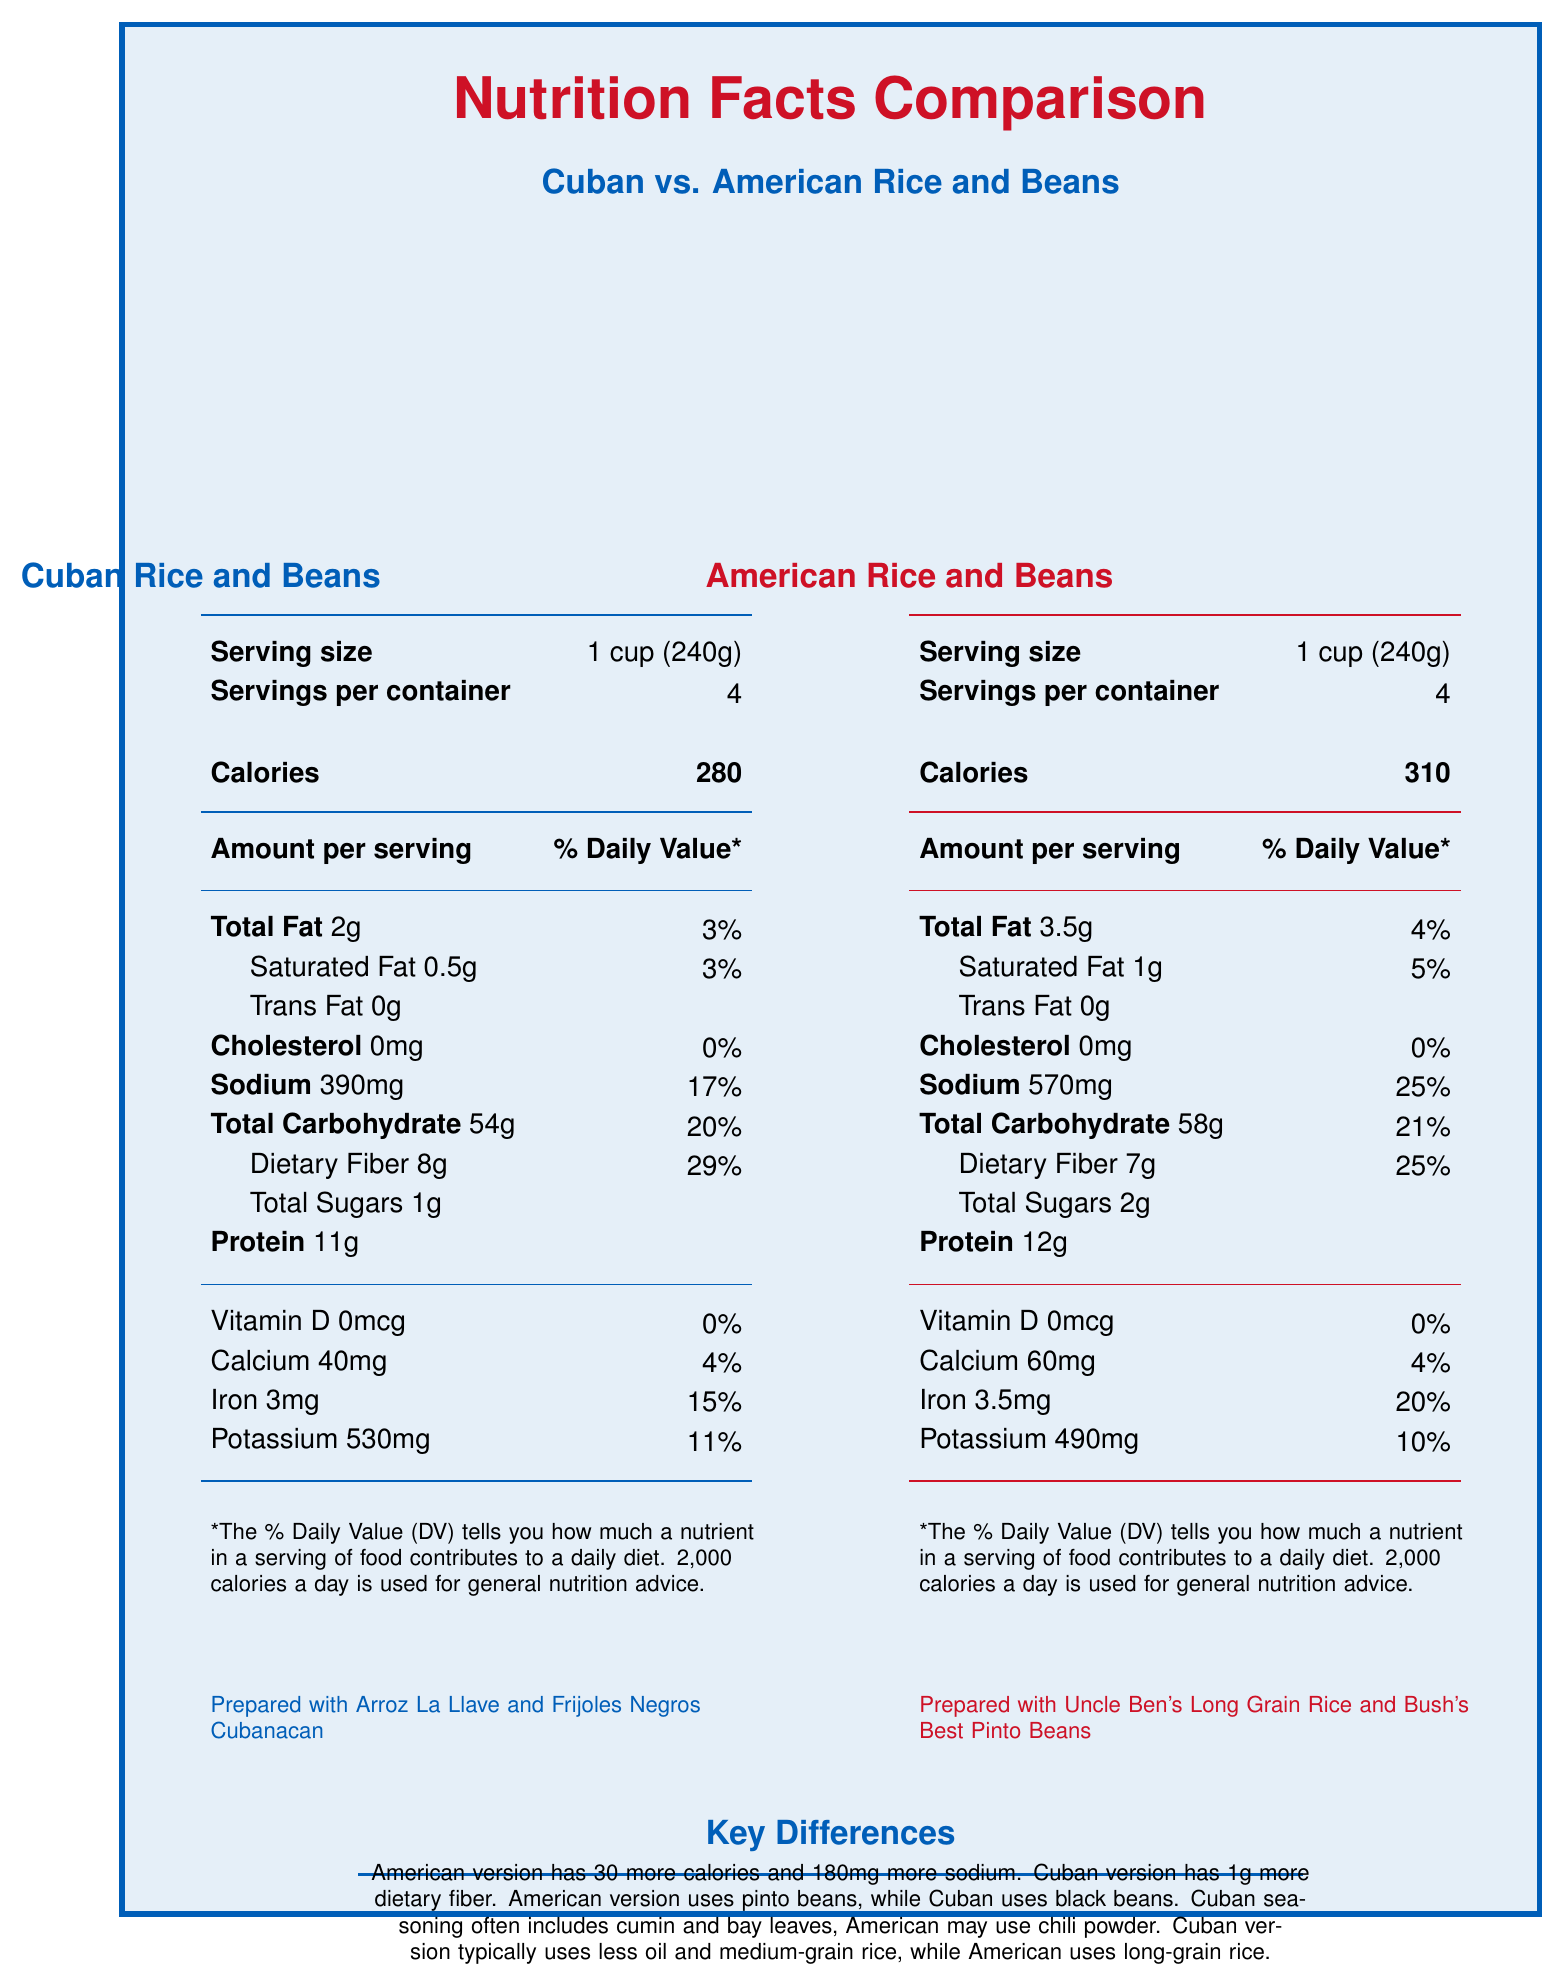what is the serving size for both Cuban and American rice and beans? Both the Cuban and American versions have a serving size of 1 cup (240g), as indicated in the respective sections of the document.
Answer: 1 cup (240g) how many calories are in a serving of American rice and beans? The document lists the calories for the American version of rice and beans as 310 per serving.
Answer: 310 what percentage of daily value is the sodium content in Cuban rice and beans? The sodium content in the Cuban version of rice and beans is listed as 390mg, which is 17% of the daily value.
Answer: 17% which version of rice and beans has higher total fat content? The American version has 3.5g of total fat while the Cuban version has 2g.
Answer: American version what distinguishes the fiber content between the two versions? The Cuban version contains 8g of dietary fiber compared to the American version's 7g.
Answer: Cuban version has 1g more dietary fiber which of the following is an ingredient commonly used in the Cuban version of rice and beans? A. Chili powder B. Bay leaves C. Olive oil The document notes that Cuban rice and beans often include cumin and bay leaves as seasonings.
Answer: B how many milligrams of calcium are in a serving of American rice and beans? The American version contains 60mg of calcium per serving.
Answer: 60mg which version includes black beans in its preparation? A. Cuban B. American C. Both The additional information section states that the Cuban version is prepared with black beans while the American version uses pinto beans.
Answer: A is there any trans fat in either version of rice and beans? Both the Cuban and American versions list 0g of trans fat.
Answer: No compare the protein content in Cuban rice and beans to the American version. The Cuban version has 11g of protein per serving while the American version has 12g.
Answer: American version has 1g more protein what is the key difference in the type of rice used between the two versions? The comparison notes specify this difference in rice types used.
Answer: Cuban version uses medium-grain rice, American version uses long-grain rice what are the two beans mentioned as being used in these dishes? The Cuban version uses black beans, and the American version uses pinto beans.
Answer: Black beans, Pinto beans which version of rice and beans is prepared with less oil? A. Cuban B. American C. Both use the same amount of oil The comparison notes state that the Cuban version typically uses less oil in preparation.
Answer: A describe the key differences between the Cuban and American versions of rice and beans. The description summarizes the main contrasts in calories, sodium, fiber content, types of beans, seasonings, and types of rice used between the two versions, along with their oil usage.
Answer: The American version has 30 more calories and 180mg more sodium, while the Cuban version has 1g more dietary fiber. The Cuban version uses black beans and medium-grain rice and includes cumin and bay leaves as seasonings, whereas the American version uses pinto beans and long-grain rice and may use chili powder. The Cuban version typically uses less oil. what is the readiness of Vitamin D in both versions? Both the Cuban and American versions have 0mcg (0%) of Vitamin D.
Answer: 0mcg, 0% what kind of oil is used in the Cuban version? Although it is mentioned that the Cuban version uses less oil, the specific type of oil is not detailed in the document.
Answer: Not enough information 